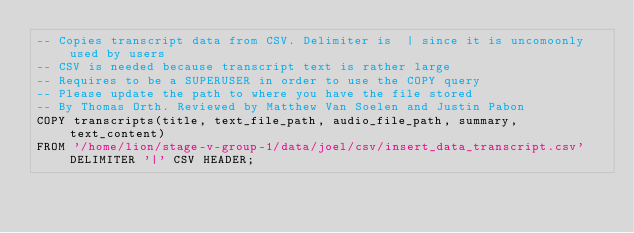Convert code to text. <code><loc_0><loc_0><loc_500><loc_500><_SQL_>-- Copies transcript data from CSV. Delimiter is  | since it is uncomoonly used by users
-- CSV is needed because transcript text is rather large
-- Requires to be a SUPERUSER in order to use the COPY query
-- Please update the path to where you have the file stored
-- By Thomas Orth. Reviewed by Matthew Van Soelen and Justin Pabon
COPY transcripts(title, text_file_path, audio_file_path, summary, text_content)
FROM '/home/lion/stage-v-group-1/data/joel/csv/insert_data_transcript.csv' DELIMITER '|' CSV HEADER;</code> 